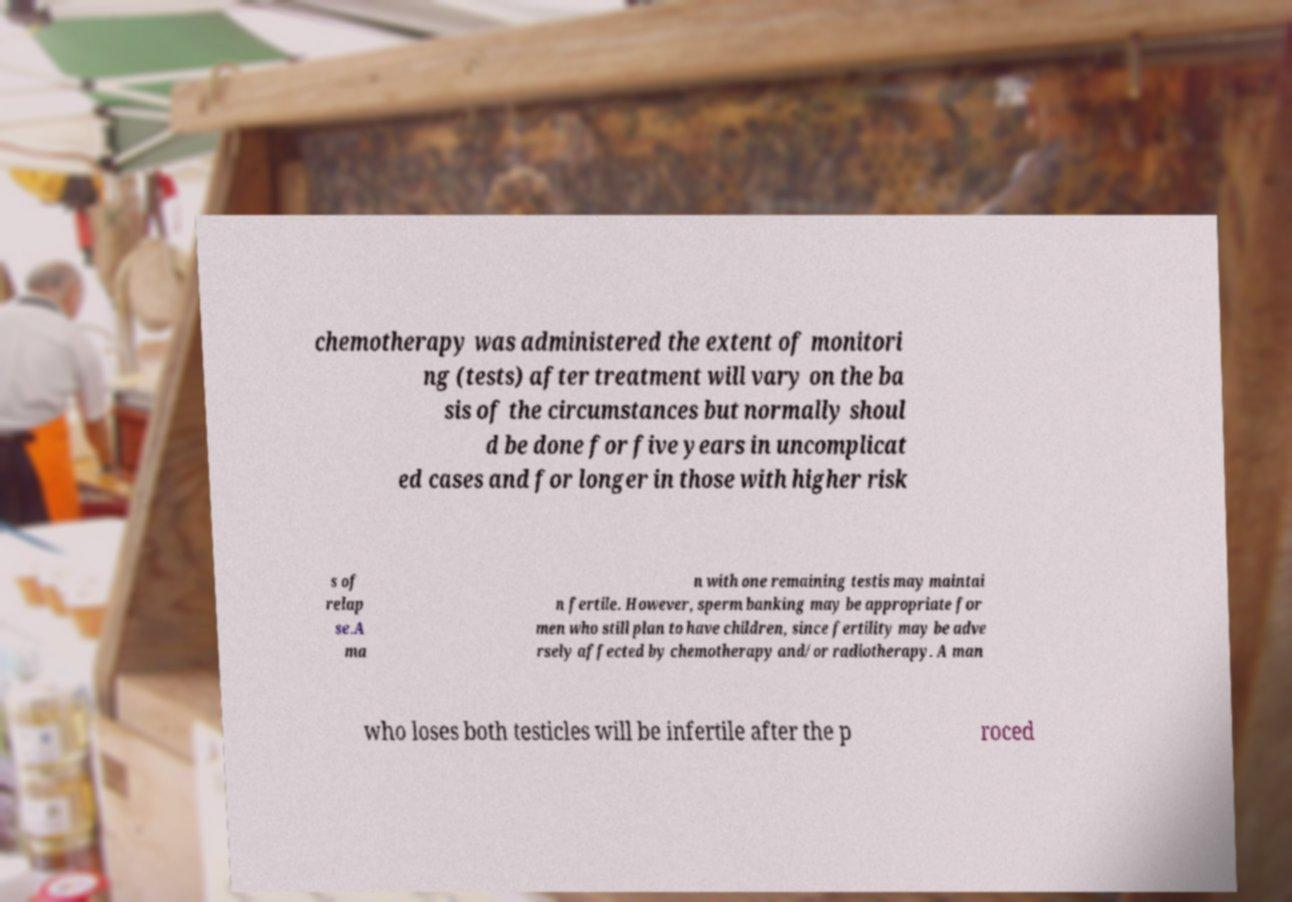I need the written content from this picture converted into text. Can you do that? chemotherapy was administered the extent of monitori ng (tests) after treatment will vary on the ba sis of the circumstances but normally shoul d be done for five years in uncomplicat ed cases and for longer in those with higher risk s of relap se.A ma n with one remaining testis may maintai n fertile. However, sperm banking may be appropriate for men who still plan to have children, since fertility may be adve rsely affected by chemotherapy and/or radiotherapy. A man who loses both testicles will be infertile after the p roced 